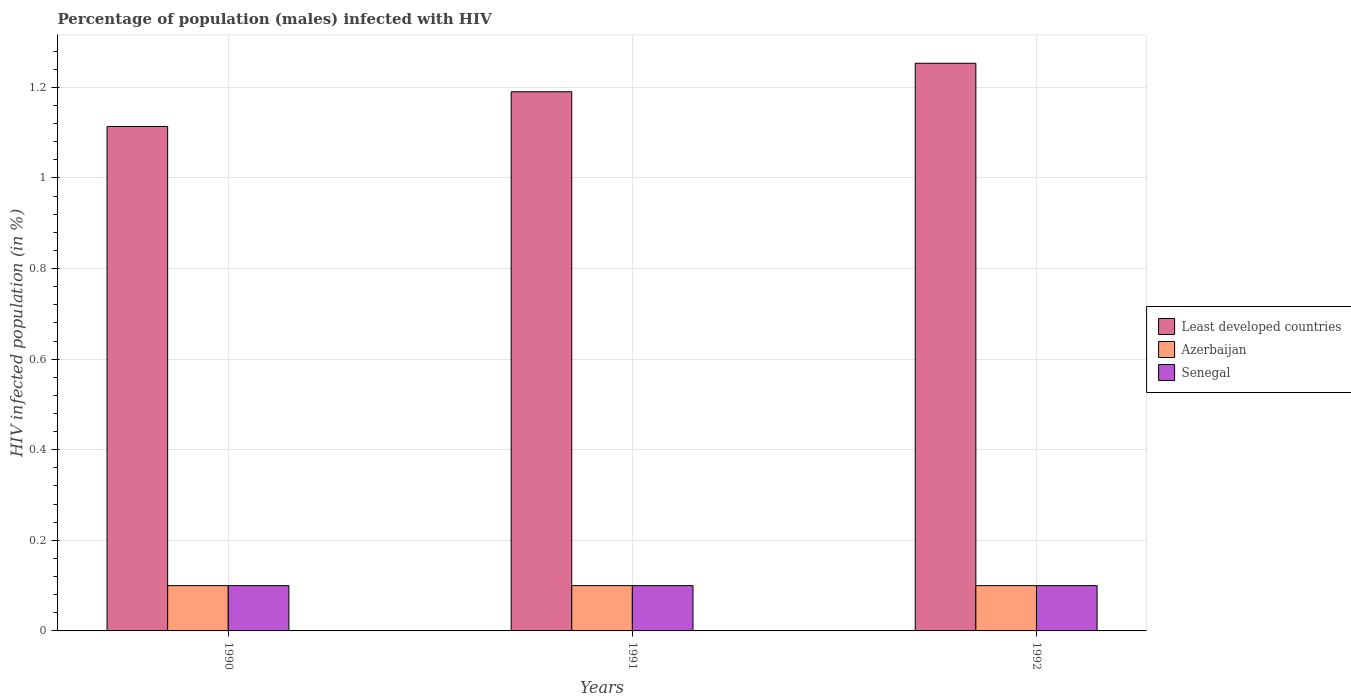How many different coloured bars are there?
Your answer should be very brief. 3. How many groups of bars are there?
Offer a very short reply. 3. Are the number of bars per tick equal to the number of legend labels?
Provide a succinct answer. Yes. What is the percentage of HIV infected male population in Senegal in 1991?
Your answer should be very brief. 0.1. Across all years, what is the maximum percentage of HIV infected male population in Least developed countries?
Offer a terse response. 1.25. Across all years, what is the minimum percentage of HIV infected male population in Least developed countries?
Give a very brief answer. 1.11. What is the total percentage of HIV infected male population in Senegal in the graph?
Make the answer very short. 0.3. What is the difference between the percentage of HIV infected male population in Azerbaijan in 1992 and the percentage of HIV infected male population in Least developed countries in 1990?
Your answer should be compact. -1.01. What is the average percentage of HIV infected male population in Azerbaijan per year?
Make the answer very short. 0.1. What is the difference between the highest and the second highest percentage of HIV infected male population in Least developed countries?
Your answer should be very brief. 0.06. What is the difference between the highest and the lowest percentage of HIV infected male population in Least developed countries?
Offer a terse response. 0.14. What does the 1st bar from the left in 1991 represents?
Keep it short and to the point. Least developed countries. What does the 2nd bar from the right in 1990 represents?
Your answer should be very brief. Azerbaijan. Are all the bars in the graph horizontal?
Make the answer very short. No. How many years are there in the graph?
Offer a terse response. 3. What is the difference between two consecutive major ticks on the Y-axis?
Make the answer very short. 0.2. Does the graph contain any zero values?
Provide a short and direct response. No. Where does the legend appear in the graph?
Ensure brevity in your answer.  Center right. How many legend labels are there?
Offer a terse response. 3. What is the title of the graph?
Your answer should be compact. Percentage of population (males) infected with HIV. What is the label or title of the X-axis?
Give a very brief answer. Years. What is the label or title of the Y-axis?
Make the answer very short. HIV infected population (in %). What is the HIV infected population (in %) of Least developed countries in 1990?
Make the answer very short. 1.11. What is the HIV infected population (in %) of Azerbaijan in 1990?
Provide a succinct answer. 0.1. What is the HIV infected population (in %) in Senegal in 1990?
Give a very brief answer. 0.1. What is the HIV infected population (in %) in Least developed countries in 1991?
Keep it short and to the point. 1.19. What is the HIV infected population (in %) of Azerbaijan in 1991?
Give a very brief answer. 0.1. What is the HIV infected population (in %) of Least developed countries in 1992?
Your answer should be compact. 1.25. What is the HIV infected population (in %) in Senegal in 1992?
Provide a short and direct response. 0.1. Across all years, what is the maximum HIV infected population (in %) of Least developed countries?
Your answer should be very brief. 1.25. Across all years, what is the maximum HIV infected population (in %) in Azerbaijan?
Keep it short and to the point. 0.1. Across all years, what is the maximum HIV infected population (in %) of Senegal?
Keep it short and to the point. 0.1. Across all years, what is the minimum HIV infected population (in %) of Least developed countries?
Your answer should be very brief. 1.11. Across all years, what is the minimum HIV infected population (in %) in Azerbaijan?
Provide a succinct answer. 0.1. What is the total HIV infected population (in %) of Least developed countries in the graph?
Offer a terse response. 3.56. What is the total HIV infected population (in %) of Azerbaijan in the graph?
Offer a very short reply. 0.3. What is the difference between the HIV infected population (in %) of Least developed countries in 1990 and that in 1991?
Ensure brevity in your answer.  -0.08. What is the difference between the HIV infected population (in %) in Azerbaijan in 1990 and that in 1991?
Your answer should be very brief. 0. What is the difference between the HIV infected population (in %) of Least developed countries in 1990 and that in 1992?
Offer a very short reply. -0.14. What is the difference between the HIV infected population (in %) of Least developed countries in 1991 and that in 1992?
Offer a very short reply. -0.06. What is the difference between the HIV infected population (in %) in Least developed countries in 1990 and the HIV infected population (in %) in Azerbaijan in 1991?
Provide a short and direct response. 1.01. What is the difference between the HIV infected population (in %) in Least developed countries in 1990 and the HIV infected population (in %) in Senegal in 1991?
Your response must be concise. 1.01. What is the difference between the HIV infected population (in %) of Azerbaijan in 1990 and the HIV infected population (in %) of Senegal in 1991?
Your response must be concise. 0. What is the difference between the HIV infected population (in %) of Least developed countries in 1990 and the HIV infected population (in %) of Azerbaijan in 1992?
Offer a terse response. 1.01. What is the difference between the HIV infected population (in %) in Least developed countries in 1990 and the HIV infected population (in %) in Senegal in 1992?
Your answer should be very brief. 1.01. What is the difference between the HIV infected population (in %) in Least developed countries in 1991 and the HIV infected population (in %) in Azerbaijan in 1992?
Keep it short and to the point. 1.09. What is the difference between the HIV infected population (in %) of Least developed countries in 1991 and the HIV infected population (in %) of Senegal in 1992?
Give a very brief answer. 1.09. What is the average HIV infected population (in %) of Least developed countries per year?
Give a very brief answer. 1.19. What is the average HIV infected population (in %) of Azerbaijan per year?
Give a very brief answer. 0.1. What is the average HIV infected population (in %) of Senegal per year?
Keep it short and to the point. 0.1. In the year 1990, what is the difference between the HIV infected population (in %) in Least developed countries and HIV infected population (in %) in Azerbaijan?
Give a very brief answer. 1.01. In the year 1990, what is the difference between the HIV infected population (in %) in Least developed countries and HIV infected population (in %) in Senegal?
Your answer should be compact. 1.01. In the year 1990, what is the difference between the HIV infected population (in %) in Azerbaijan and HIV infected population (in %) in Senegal?
Your response must be concise. 0. In the year 1991, what is the difference between the HIV infected population (in %) of Least developed countries and HIV infected population (in %) of Azerbaijan?
Make the answer very short. 1.09. In the year 1991, what is the difference between the HIV infected population (in %) in Least developed countries and HIV infected population (in %) in Senegal?
Offer a very short reply. 1.09. In the year 1991, what is the difference between the HIV infected population (in %) of Azerbaijan and HIV infected population (in %) of Senegal?
Your answer should be compact. 0. In the year 1992, what is the difference between the HIV infected population (in %) in Least developed countries and HIV infected population (in %) in Azerbaijan?
Your response must be concise. 1.15. In the year 1992, what is the difference between the HIV infected population (in %) of Least developed countries and HIV infected population (in %) of Senegal?
Ensure brevity in your answer.  1.15. In the year 1992, what is the difference between the HIV infected population (in %) in Azerbaijan and HIV infected population (in %) in Senegal?
Your response must be concise. 0. What is the ratio of the HIV infected population (in %) in Least developed countries in 1990 to that in 1991?
Provide a succinct answer. 0.94. What is the ratio of the HIV infected population (in %) in Senegal in 1990 to that in 1991?
Offer a very short reply. 1. What is the ratio of the HIV infected population (in %) in Least developed countries in 1990 to that in 1992?
Give a very brief answer. 0.89. What is the ratio of the HIV infected population (in %) in Azerbaijan in 1990 to that in 1992?
Your answer should be compact. 1. What is the ratio of the HIV infected population (in %) in Senegal in 1990 to that in 1992?
Offer a very short reply. 1. What is the ratio of the HIV infected population (in %) in Least developed countries in 1991 to that in 1992?
Provide a short and direct response. 0.95. What is the difference between the highest and the second highest HIV infected population (in %) of Least developed countries?
Give a very brief answer. 0.06. What is the difference between the highest and the lowest HIV infected population (in %) in Least developed countries?
Your answer should be very brief. 0.14. What is the difference between the highest and the lowest HIV infected population (in %) of Azerbaijan?
Provide a succinct answer. 0. What is the difference between the highest and the lowest HIV infected population (in %) in Senegal?
Your answer should be very brief. 0. 